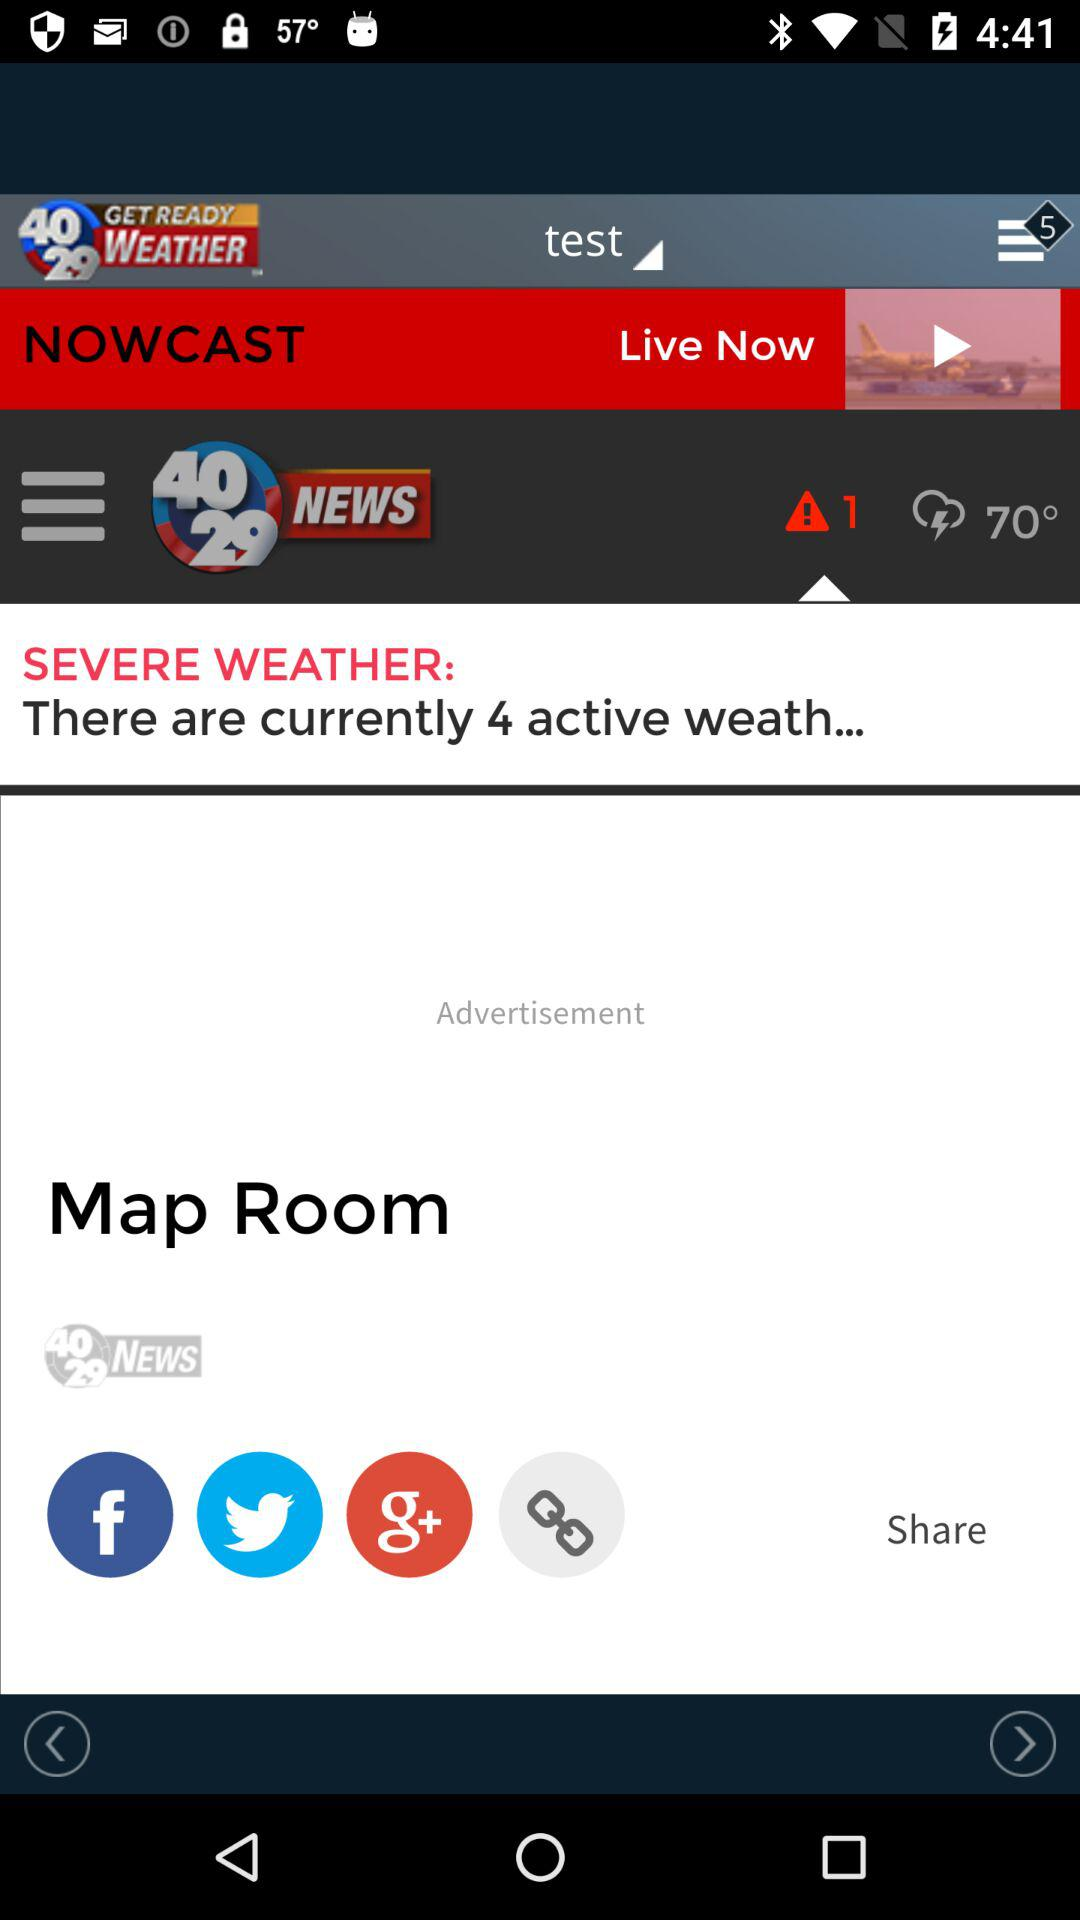What's the number of alert notifications? The number is 1. 